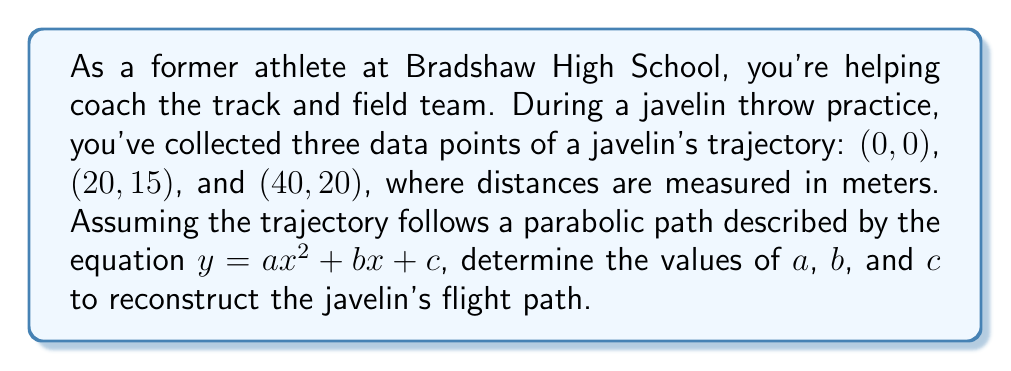What is the answer to this math problem? Let's approach this step-by-step:

1) We know that the parabola passes through three points: (0, 0), (20, 15), and (40, 20).

2) Substituting these points into the general equation $y = ax^2 + bx + c$:

   For (0, 0): $0 = a(0)^2 + b(0) + c$, so $c = 0$

   For (20, 15): $15 = a(20)^2 + b(20) + 0$
   
   For (40, 20): $20 = a(40)^2 + b(40) + 0$

3) From the equation for (20, 15):
   $15 = 400a + 20b$ ... (Equation 1)

4) From the equation for (40, 20):
   $20 = 1600a + 40b$ ... (Equation 2)

5) Multiply Equation 1 by 2:
   $30 = 800a + 40b$ ... (Equation 3)

6) Subtract Equation 2 from Equation 3:
   $10 = -800a$

7) Solve for $a$:
   $a = -\frac{1}{80} = -0.0125$

8) Substitute this value of $a$ back into Equation 1:
   $15 = 400(-0.0125) + 20b$
   $15 = -5 + 20b$
   $20 = 20b$
   $b = 1$

9) We already know that $c = 0$ from step 2.

Therefore, the parabolic equation of the javelin's trajectory is:

$y = -0.0125x^2 + x$
Answer: $y = -0.0125x^2 + x$ 